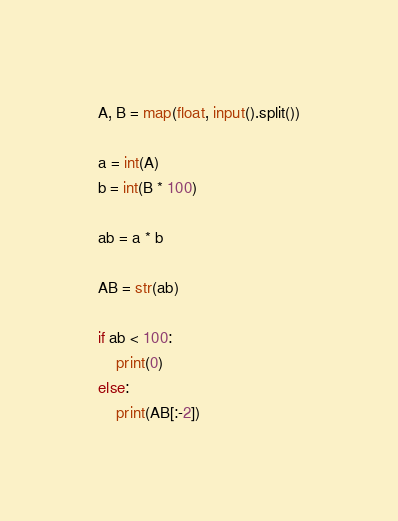<code> <loc_0><loc_0><loc_500><loc_500><_Python_>A, B = map(float, input().split())

a = int(A)
b = int(B * 100)

ab = a * b

AB = str(ab)

if ab < 100:
    print(0)
else:
    print(AB[:-2])</code> 